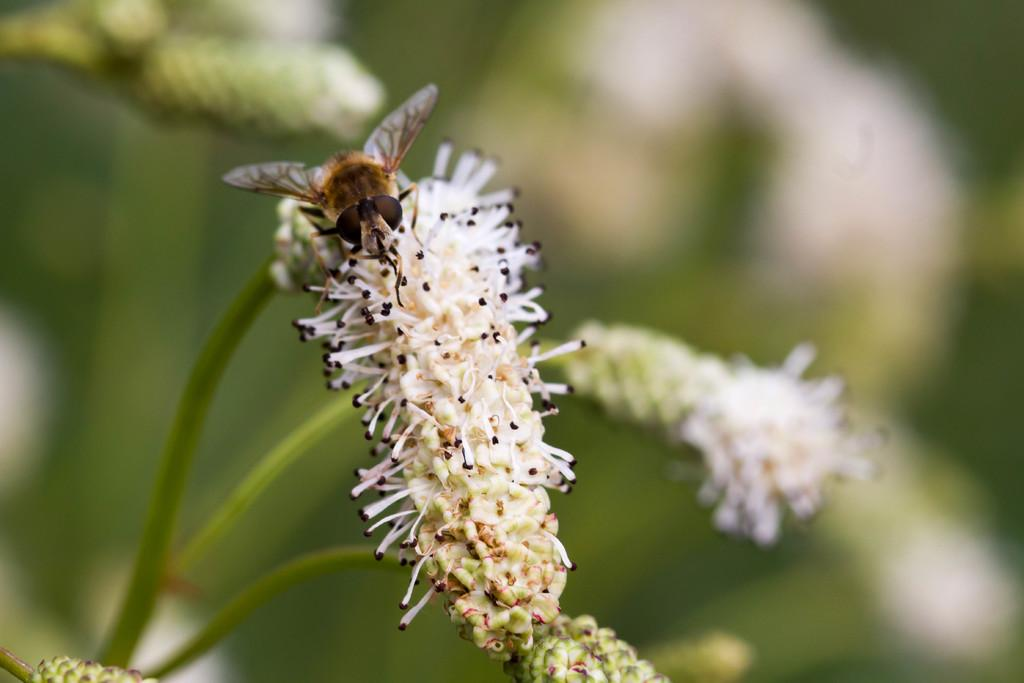What is the main subject of the image? The main subject of the image is an insect on a flower. Can you describe the background of the image? The background of the image is blurred. What type of horn can be seen on the insect in the image? There is no horn visible on the insect in the image. Is there a shop in the background of the image? There is no shop present in the image; the background is blurred. 